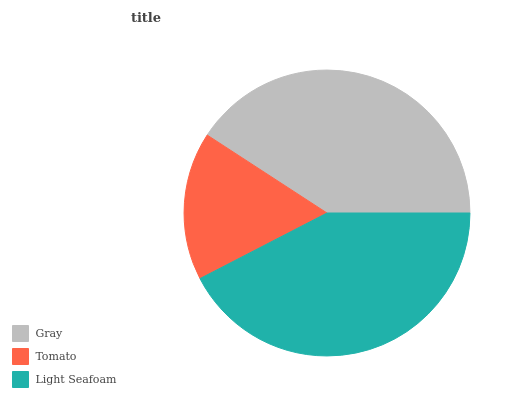Is Tomato the minimum?
Answer yes or no. Yes. Is Light Seafoam the maximum?
Answer yes or no. Yes. Is Light Seafoam the minimum?
Answer yes or no. No. Is Tomato the maximum?
Answer yes or no. No. Is Light Seafoam greater than Tomato?
Answer yes or no. Yes. Is Tomato less than Light Seafoam?
Answer yes or no. Yes. Is Tomato greater than Light Seafoam?
Answer yes or no. No. Is Light Seafoam less than Tomato?
Answer yes or no. No. Is Gray the high median?
Answer yes or no. Yes. Is Gray the low median?
Answer yes or no. Yes. Is Tomato the high median?
Answer yes or no. No. Is Tomato the low median?
Answer yes or no. No. 